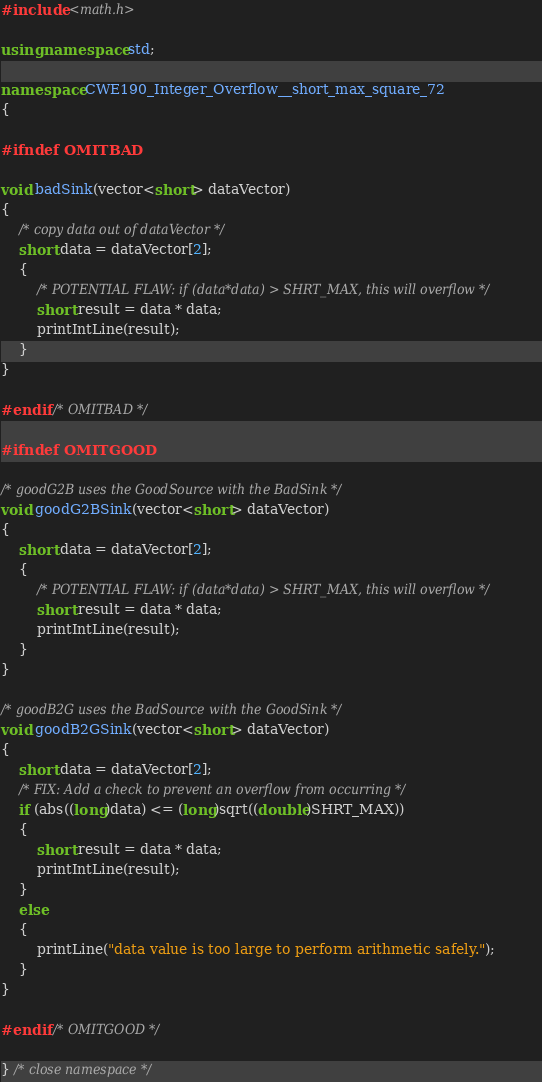Convert code to text. <code><loc_0><loc_0><loc_500><loc_500><_C++_>
#include <math.h>

using namespace std;

namespace CWE190_Integer_Overflow__short_max_square_72
{

#ifndef OMITBAD

void badSink(vector<short> dataVector)
{
    /* copy data out of dataVector */
    short data = dataVector[2];
    {
        /* POTENTIAL FLAW: if (data*data) > SHRT_MAX, this will overflow */
        short result = data * data;
        printIntLine(result);
    }
}

#endif /* OMITBAD */

#ifndef OMITGOOD

/* goodG2B uses the GoodSource with the BadSink */
void goodG2BSink(vector<short> dataVector)
{
    short data = dataVector[2];
    {
        /* POTENTIAL FLAW: if (data*data) > SHRT_MAX, this will overflow */
        short result = data * data;
        printIntLine(result);
    }
}

/* goodB2G uses the BadSource with the GoodSink */
void goodB2GSink(vector<short> dataVector)
{
    short data = dataVector[2];
    /* FIX: Add a check to prevent an overflow from occurring */
    if (abs((long)data) <= (long)sqrt((double)SHRT_MAX))
    {
        short result = data * data;
        printIntLine(result);
    }
    else
    {
        printLine("data value is too large to perform arithmetic safely.");
    }
}

#endif /* OMITGOOD */

} /* close namespace */
</code> 